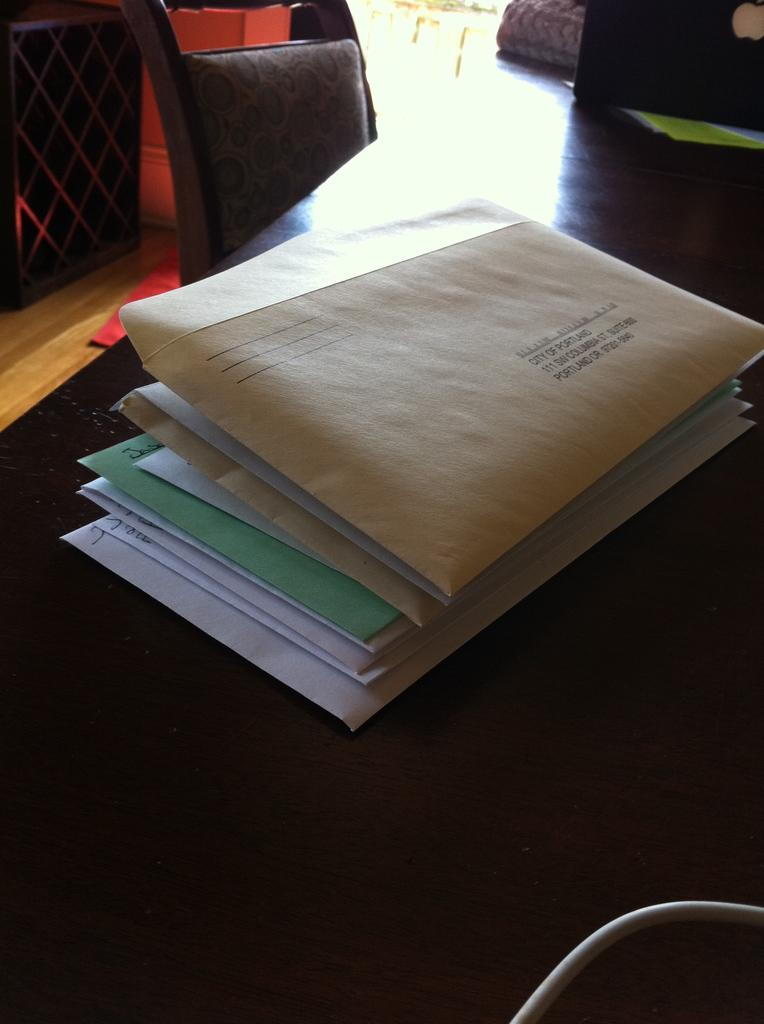What items are related to mailing or correspondence in the image? There are papers with envelopes in the image. What type of furniture is present in the image? There is a chair in the image. What color is the goldfish swimming in the chair in the image? There is no goldfish present in the image; it only features papers with envelopes and a chair. 